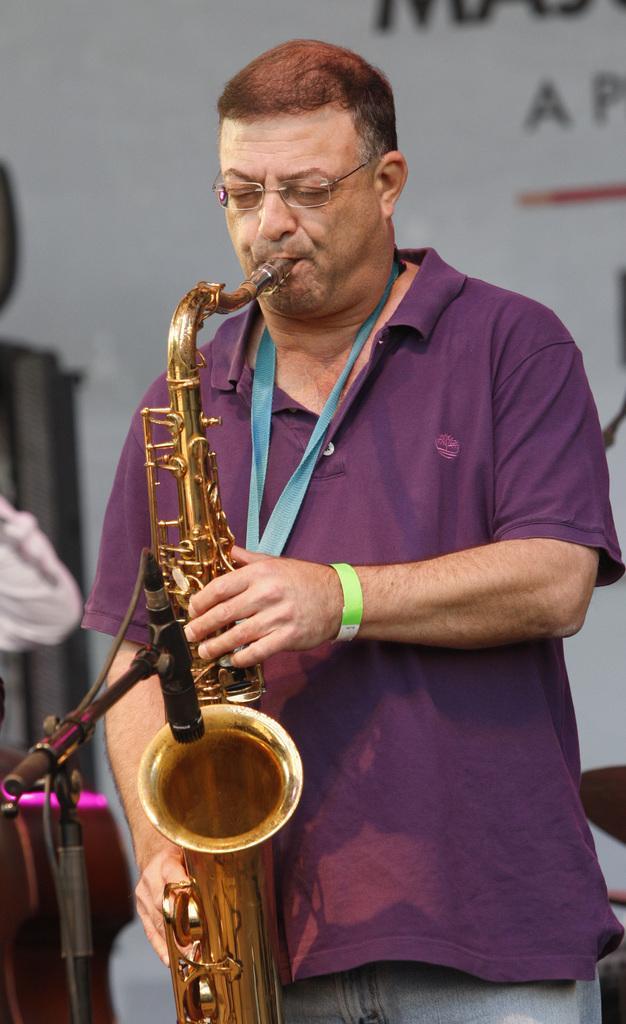In one or two sentences, can you explain what this image depicts? In this image we can see a person is standing and he is playing musical instrument. He is wearing purple color jacket. Left bottom of the image mic and stand is there. Background of the image poster is present. 